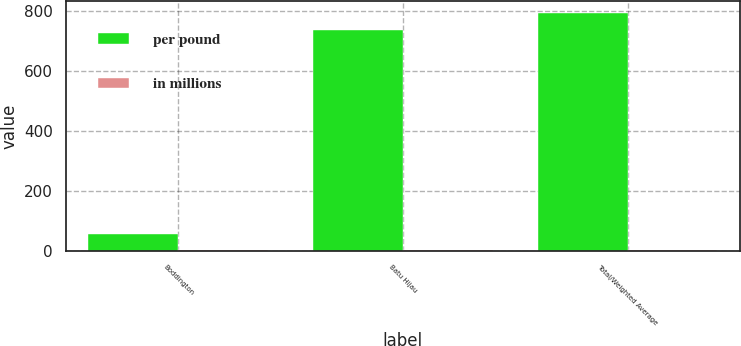<chart> <loc_0><loc_0><loc_500><loc_500><stacked_bar_chart><ecel><fcel>Boddington<fcel>Batu Hijau<fcel>Total/Weighted Average<nl><fcel>per pound<fcel>56<fcel>737<fcel>793<nl><fcel>in millions<fcel>0.95<fcel>0.47<fcel>0.49<nl></chart> 